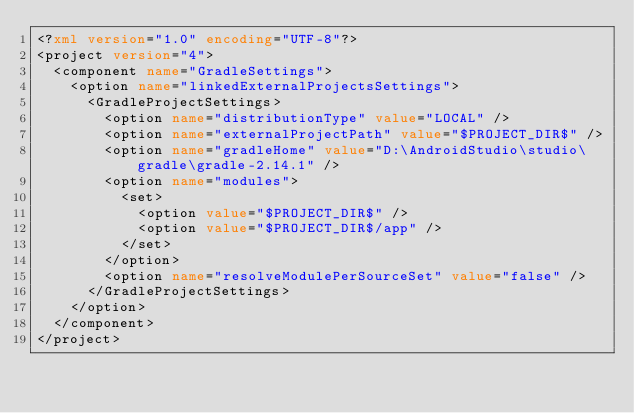Convert code to text. <code><loc_0><loc_0><loc_500><loc_500><_XML_><?xml version="1.0" encoding="UTF-8"?>
<project version="4">
  <component name="GradleSettings">
    <option name="linkedExternalProjectsSettings">
      <GradleProjectSettings>
        <option name="distributionType" value="LOCAL" />
        <option name="externalProjectPath" value="$PROJECT_DIR$" />
        <option name="gradleHome" value="D:\AndroidStudio\studio\gradle\gradle-2.14.1" />
        <option name="modules">
          <set>
            <option value="$PROJECT_DIR$" />
            <option value="$PROJECT_DIR$/app" />
          </set>
        </option>
        <option name="resolveModulePerSourceSet" value="false" />
      </GradleProjectSettings>
    </option>
  </component>
</project></code> 